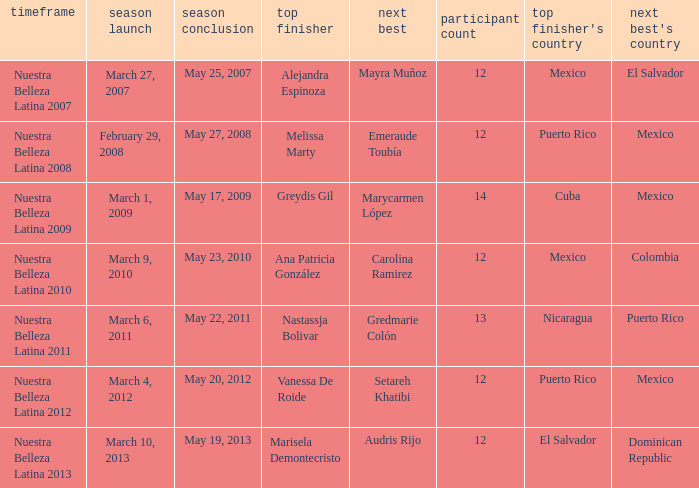What season had mexico as the runner up with melissa marty winning? Nuestra Belleza Latina 2008. 